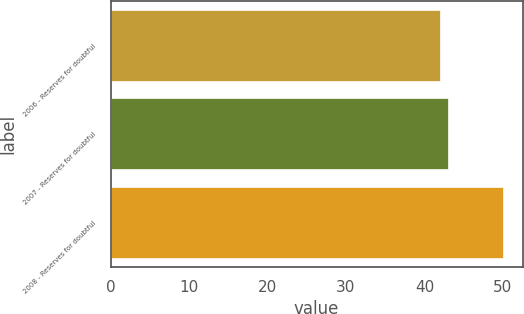Convert chart. <chart><loc_0><loc_0><loc_500><loc_500><bar_chart><fcel>2006 - Reserves for doubtful<fcel>2007 - Reserves for doubtful<fcel>2008 - Reserves for doubtful<nl><fcel>42<fcel>43<fcel>50<nl></chart> 